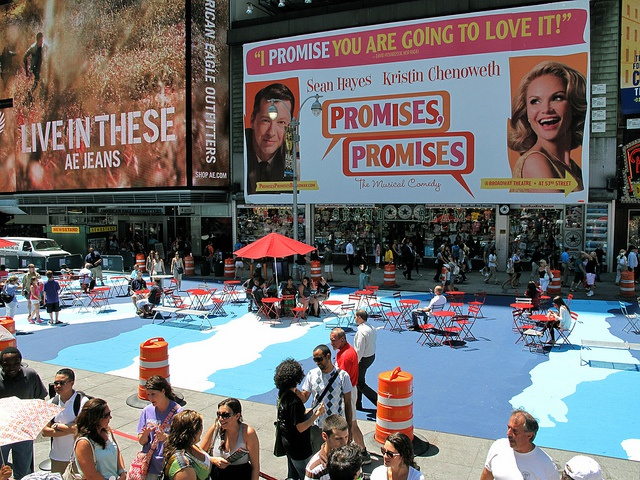Describe the objects in this image and their specific colors. I can see people in black, gray, brown, and maroon tones, people in black, gray, and maroon tones, people in black, white, darkgray, and brown tones, people in black, gray, and maroon tones, and chair in black, white, and lightblue tones in this image. 